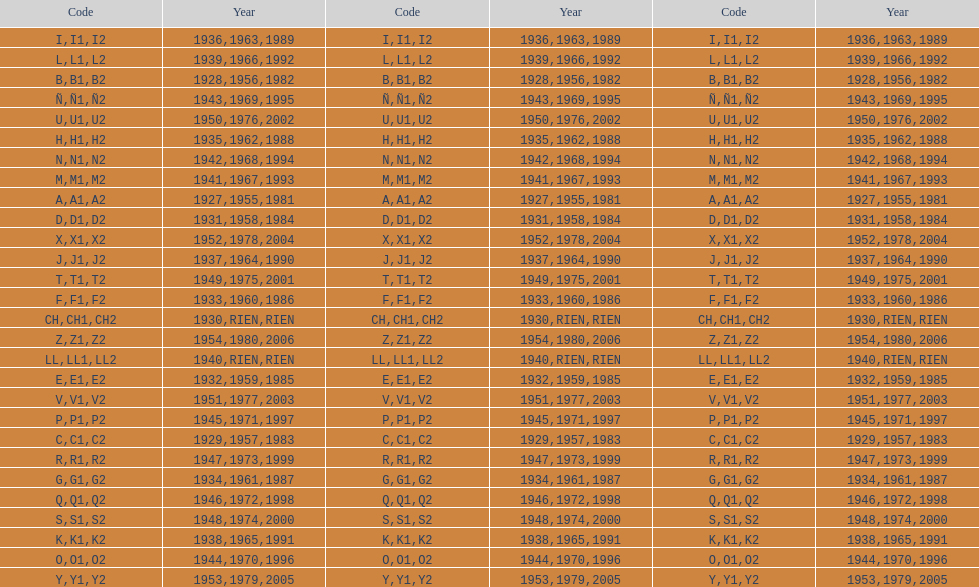Is the e code less than 1950? Yes. 